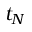Convert formula to latex. <formula><loc_0><loc_0><loc_500><loc_500>t _ { N }</formula> 